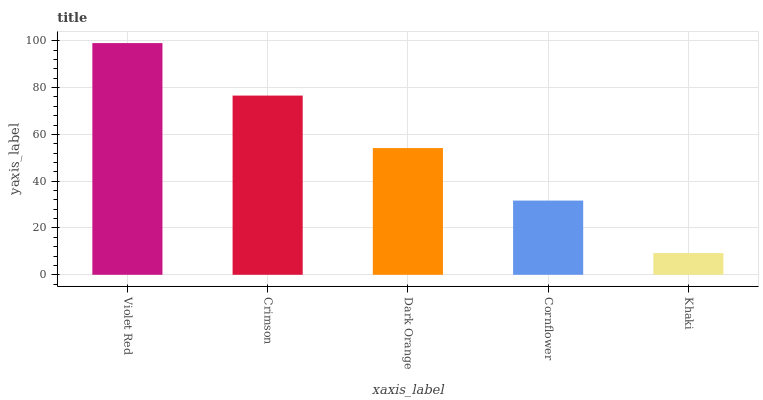Is Khaki the minimum?
Answer yes or no. Yes. Is Violet Red the maximum?
Answer yes or no. Yes. Is Crimson the minimum?
Answer yes or no. No. Is Crimson the maximum?
Answer yes or no. No. Is Violet Red greater than Crimson?
Answer yes or no. Yes. Is Crimson less than Violet Red?
Answer yes or no. Yes. Is Crimson greater than Violet Red?
Answer yes or no. No. Is Violet Red less than Crimson?
Answer yes or no. No. Is Dark Orange the high median?
Answer yes or no. Yes. Is Dark Orange the low median?
Answer yes or no. Yes. Is Khaki the high median?
Answer yes or no. No. Is Cornflower the low median?
Answer yes or no. No. 